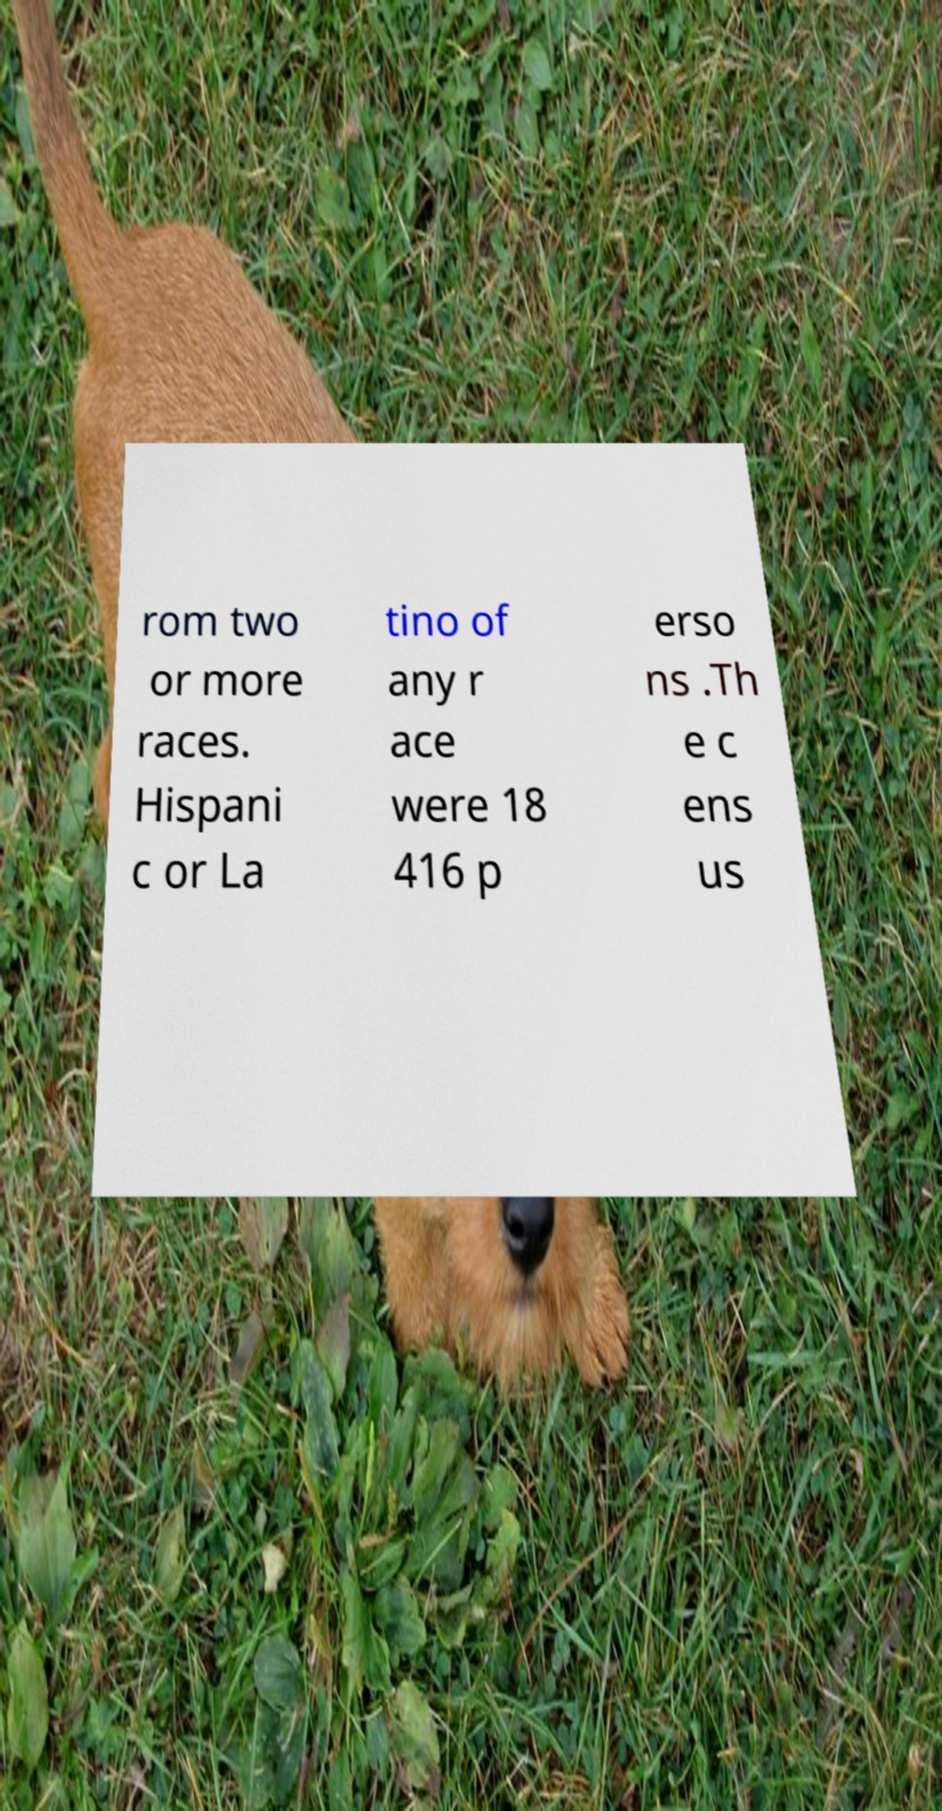There's text embedded in this image that I need extracted. Can you transcribe it verbatim? rom two or more races. Hispani c or La tino of any r ace were 18 416 p erso ns .Th e c ens us 